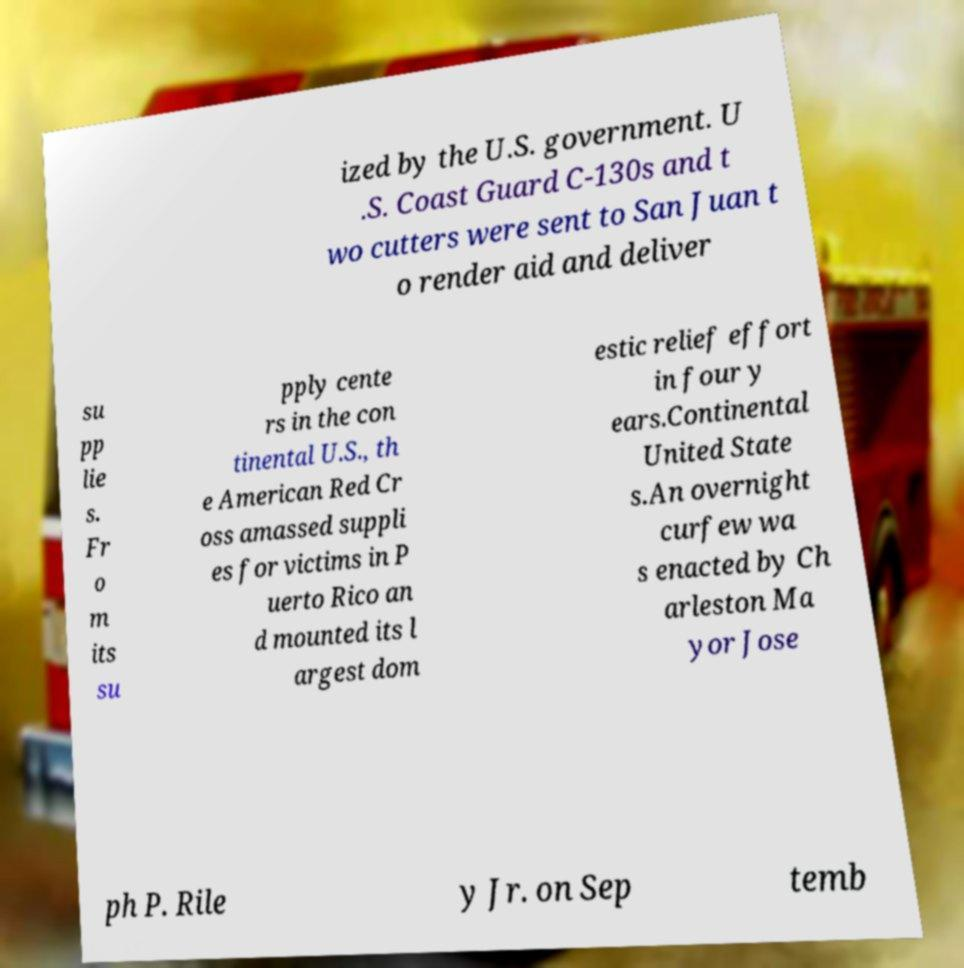For documentation purposes, I need the text within this image transcribed. Could you provide that? ized by the U.S. government. U .S. Coast Guard C-130s and t wo cutters were sent to San Juan t o render aid and deliver su pp lie s. Fr o m its su pply cente rs in the con tinental U.S., th e American Red Cr oss amassed suppli es for victims in P uerto Rico an d mounted its l argest dom estic relief effort in four y ears.Continental United State s.An overnight curfew wa s enacted by Ch arleston Ma yor Jose ph P. Rile y Jr. on Sep temb 